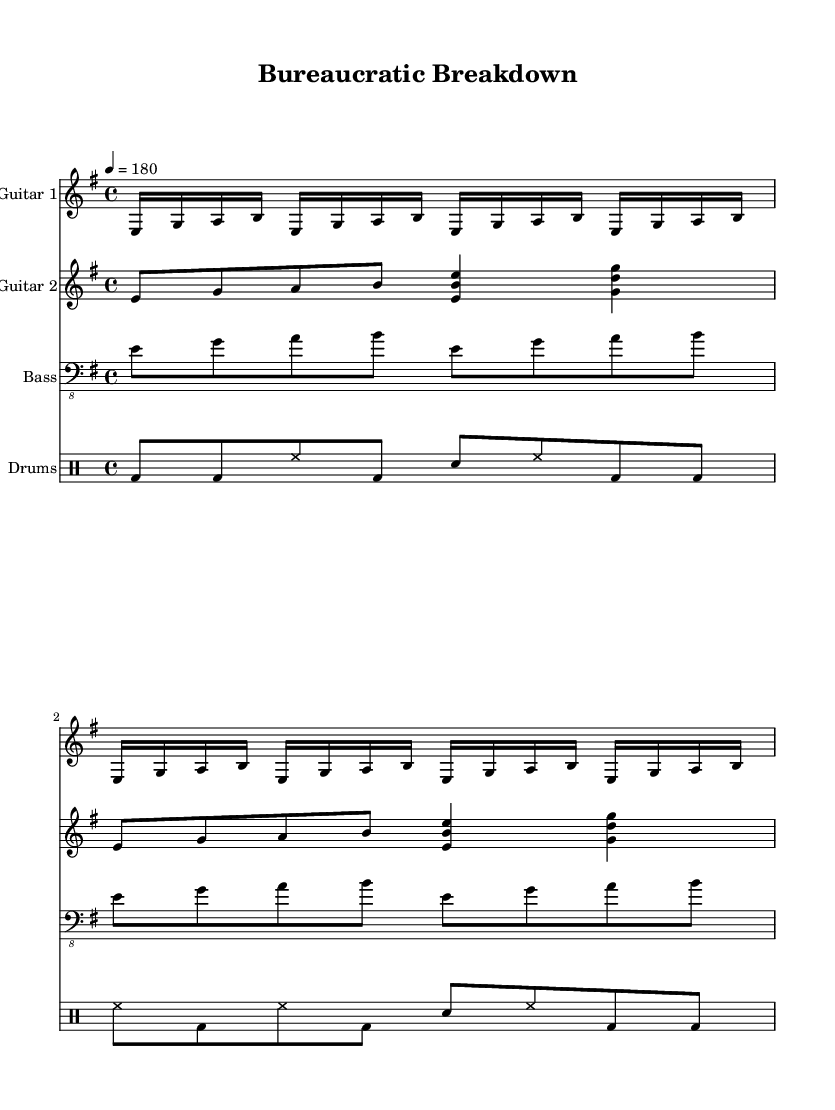What is the key signature of this music? The key signature is E minor, which has one sharp (F#).
Answer: E minor What is the time signature of this music? The time signature is 4/4, which indicates four beats per measure.
Answer: 4/4 What is the tempo marking for this piece? The tempo marking is quarter note equals 180, meaning 180 beats per minute.
Answer: 180 How many measures are in the guitar part? The guitar part contains 8 measures in total, as indicated by the notation.
Answer: 8 measures Which instruments are used in this piece? The instruments used are two electric guitars, bass, and drums.
Answer: Electric guitars, bass, drums Which clef is used for the bass part? The bass part uses a bass clef, which is represented by the lower staff notation.
Answer: Bass clef What rhythmic figure is primarily used in the drum part? The rhythmic figure is a combination of bass drum and hi-hat patterns that repeat frequently.
Answer: Bass drum and hi-hat patterns 